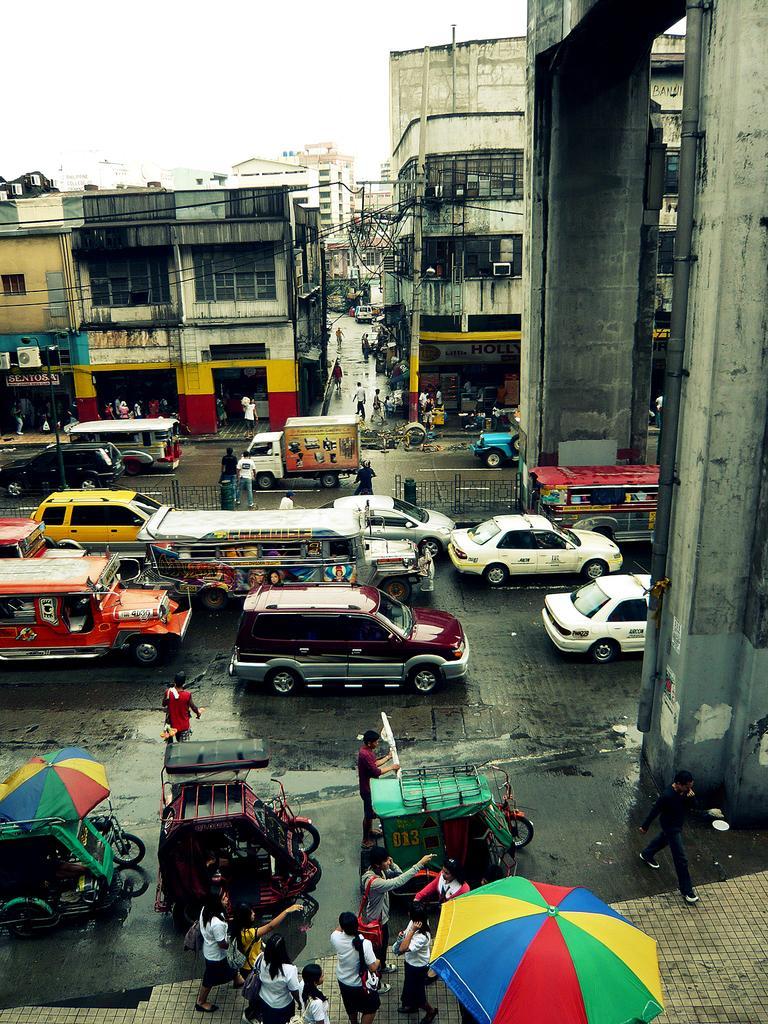Could you give a brief overview of what you see in this image? In the image we can see there are vehicles on the road. We can even see buildings. There are people walking and some of them are standing, they are wearing clothes. Here we can see umbrellas, road, fence and the sky. 